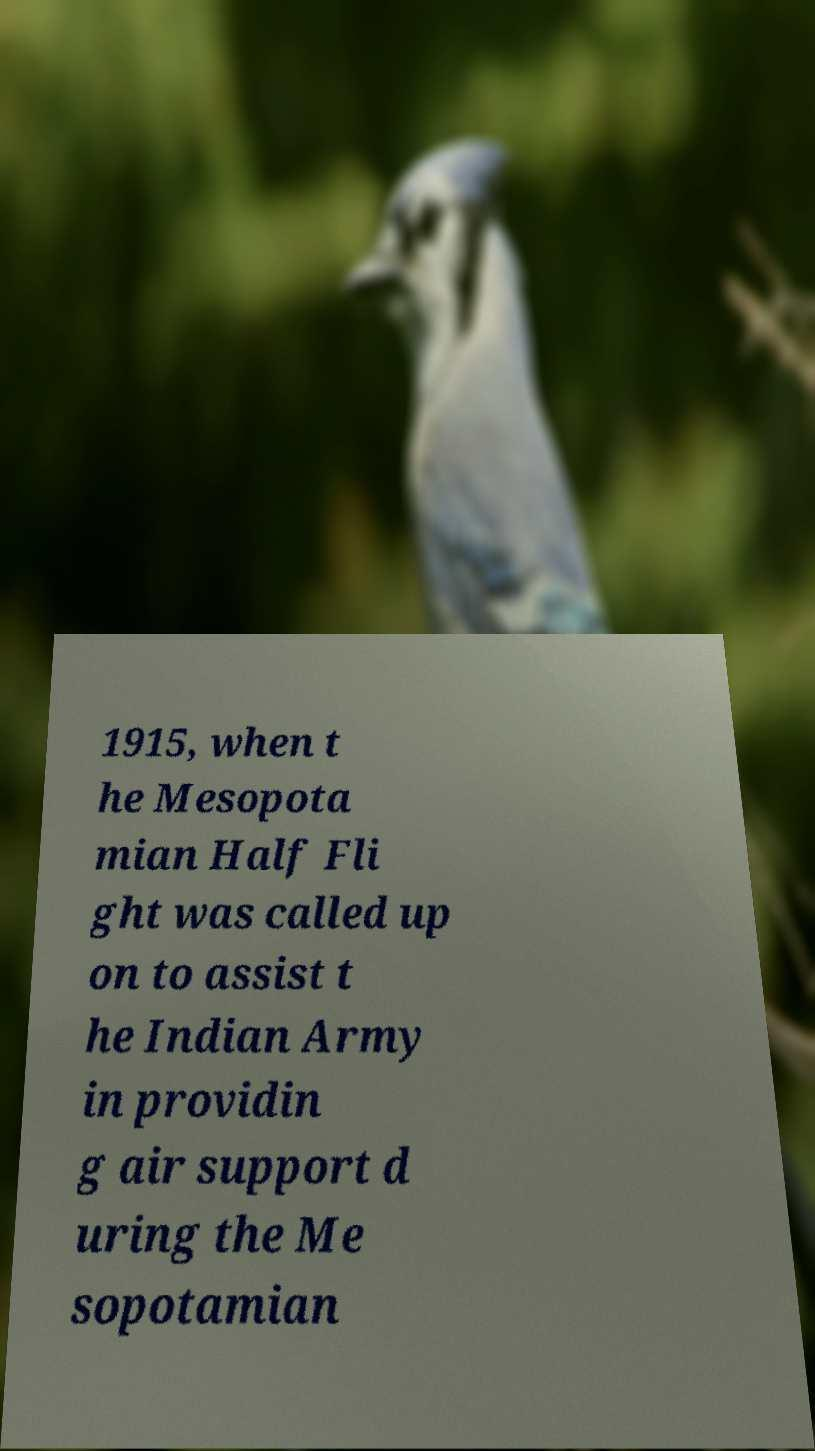Could you extract and type out the text from this image? 1915, when t he Mesopota mian Half Fli ght was called up on to assist t he Indian Army in providin g air support d uring the Me sopotamian 